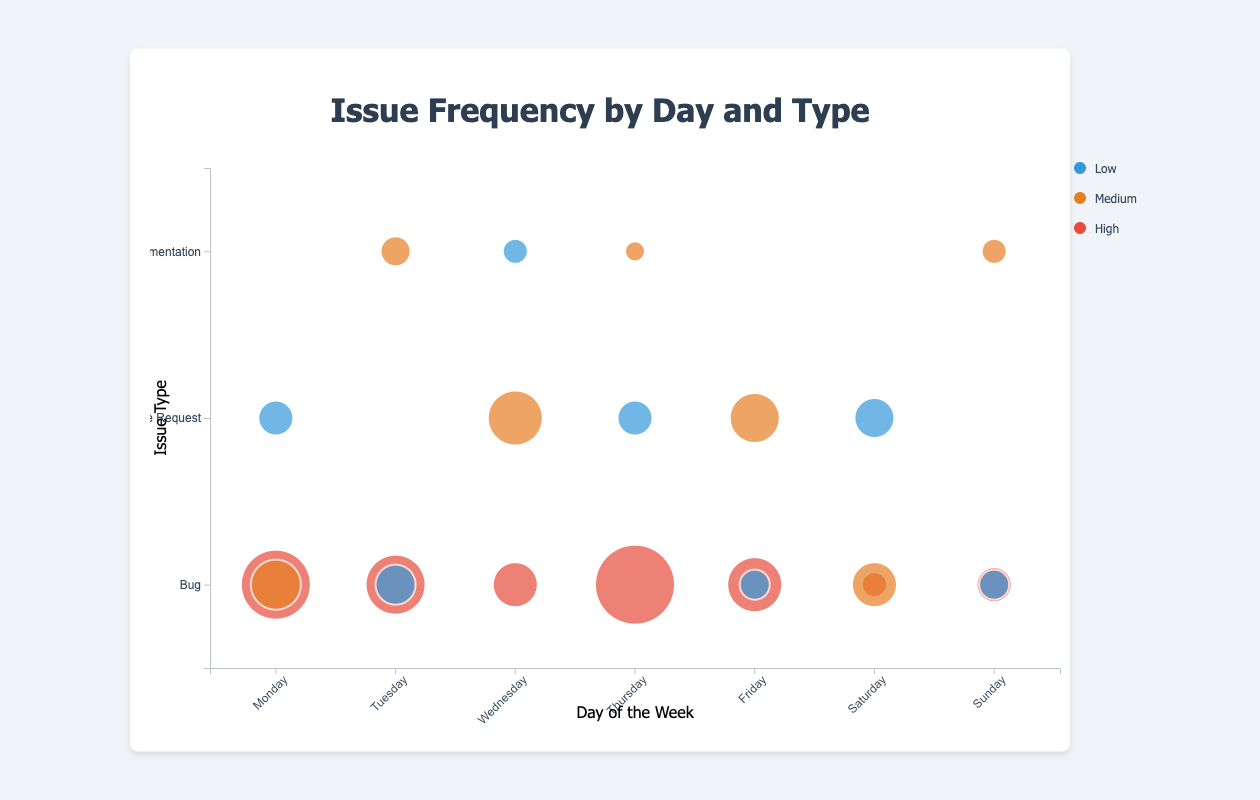What's the most frequently reported high severity issue on Monday? To find the most frequently reported high severity issue on Monday, look for the largest bubble within "Bug" issue type at the "High" severity level on Monday. Based on the bubble size, the frequency is 12 for "Bug" with high severity.
Answer: Bug Which day has the highest frequency of high severity bugs? To determine this, observe all bubbles under the high severity category and compare their sizes across different days. Thursday has the largest bubble for high severity bugs, with a frequency of 14.
Answer: Thursday How many issues were reported on Wednesday for feature requests with medium severity? Identify the medium severity bubbles for feature requests on Wednesday. There's one bubble, and its size corresponds to a frequency of 9.
Answer: 9 Which issue type has the most high severity reports in the dataset, regardless of the day? Sum the frequencies of high severity issues for each issue type across all days. "Bug" has the frequencies of 12 (Mon) + 10 (Tues) + 7 (Wed) + 14 (Thu) + 9 (Fri) + 3 (Sat) + 5 (Sun) = 60, "Feature Request" and "Documentation" have no high severity issues. Therefore, "Bug" has the most high severity reports.
Answer: Bug Compare the frequency of low severity bugs on Tuesday and Sunday. Which day had more? Check the bubbles for low severity bugs on Tuesday and Sunday, and compare their sizes. Tuesday has a frequency of 6, while Sunday has a frequency of 4. Hence, Tuesday had more low severity bugs.
Answer: Tuesday What is the total number of feature requests reported throughout the week? Sum the frequencies of feature requests across all days: 5 (Mon) + 9 (Wed) + 5 (Thu) + 8 (Fri) + 6 (Sat) = 33.
Answer: 33 Which day has the fewest total issues reported? Sum the frequencies of all issues reported each day across all severities and issue types:
- Monday: 12 + 8 + 5 = 25
- Tuesday: 10 + 6 + 4 = 20
- Wednesday: 7 + 9 + 3 = 19
- Thursday: 14 + 5 + 2 = 21
- Friday: 9 + 8 + 4 = 21
- Saturday: 3 + 7 + 6 = 16
- Sunday: 5 + 4 + 3 = 12
Sunday has the fewest total issues reported, with 12.
Answer: Sunday How does the frequency of documentation issues compare between Tuesday and Thursday? Compare the sizes of the bubbles for documentation issues on Tuesday and Thursday. Tuesday has a medium severity bubble with a frequency of 4, while Thursday has a medium severity bubble with a frequency of 2. Thus, Tuesday has a higher frequency.
Answer: Tuesday 